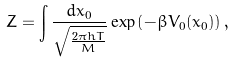Convert formula to latex. <formula><loc_0><loc_0><loc_500><loc_500>Z = \int { \frac { d x _ { 0 } } { \sqrt { \frac { 2 \pi \bar { h } T } { M } } } } \exp \left ( - { \beta } V _ { 0 } ( x _ { 0 } ) \right ) ,</formula> 